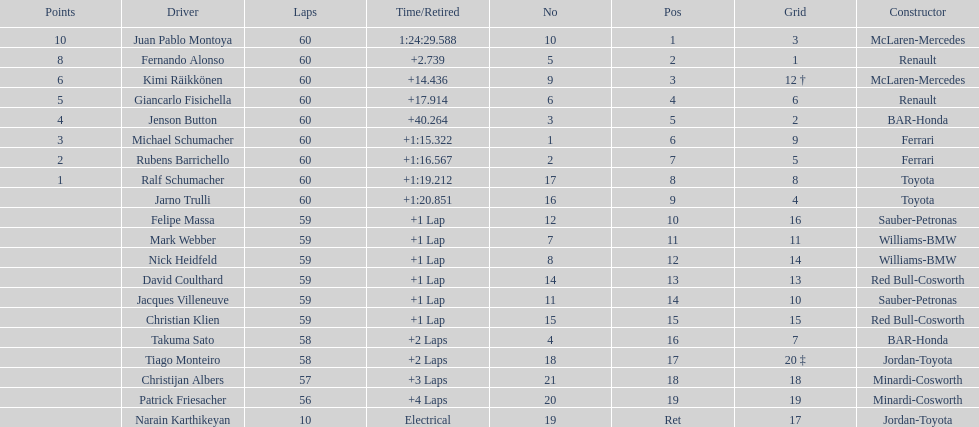Which driver has the least amount of points? Ralf Schumacher. Write the full table. {'header': ['Points', 'Driver', 'Laps', 'Time/Retired', 'No', 'Pos', 'Grid', 'Constructor'], 'rows': [['10', 'Juan Pablo Montoya', '60', '1:24:29.588', '10', '1', '3', 'McLaren-Mercedes'], ['8', 'Fernando Alonso', '60', '+2.739', '5', '2', '1', 'Renault'], ['6', 'Kimi Räikkönen', '60', '+14.436', '9', '3', '12 †', 'McLaren-Mercedes'], ['5', 'Giancarlo Fisichella', '60', '+17.914', '6', '4', '6', 'Renault'], ['4', 'Jenson Button', '60', '+40.264', '3', '5', '2', 'BAR-Honda'], ['3', 'Michael Schumacher', '60', '+1:15.322', '1', '6', '9', 'Ferrari'], ['2', 'Rubens Barrichello', '60', '+1:16.567', '2', '7', '5', 'Ferrari'], ['1', 'Ralf Schumacher', '60', '+1:19.212', '17', '8', '8', 'Toyota'], ['', 'Jarno Trulli', '60', '+1:20.851', '16', '9', '4', 'Toyota'], ['', 'Felipe Massa', '59', '+1 Lap', '12', '10', '16', 'Sauber-Petronas'], ['', 'Mark Webber', '59', '+1 Lap', '7', '11', '11', 'Williams-BMW'], ['', 'Nick Heidfeld', '59', '+1 Lap', '8', '12', '14', 'Williams-BMW'], ['', 'David Coulthard', '59', '+1 Lap', '14', '13', '13', 'Red Bull-Cosworth'], ['', 'Jacques Villeneuve', '59', '+1 Lap', '11', '14', '10', 'Sauber-Petronas'], ['', 'Christian Klien', '59', '+1 Lap', '15', '15', '15', 'Red Bull-Cosworth'], ['', 'Takuma Sato', '58', '+2 Laps', '4', '16', '7', 'BAR-Honda'], ['', 'Tiago Monteiro', '58', '+2 Laps', '18', '17', '20 ‡', 'Jordan-Toyota'], ['', 'Christijan Albers', '57', '+3 Laps', '21', '18', '18', 'Minardi-Cosworth'], ['', 'Patrick Friesacher', '56', '+4 Laps', '20', '19', '19', 'Minardi-Cosworth'], ['', 'Narain Karthikeyan', '10', 'Electrical', '19', 'Ret', '17', 'Jordan-Toyota']]} 